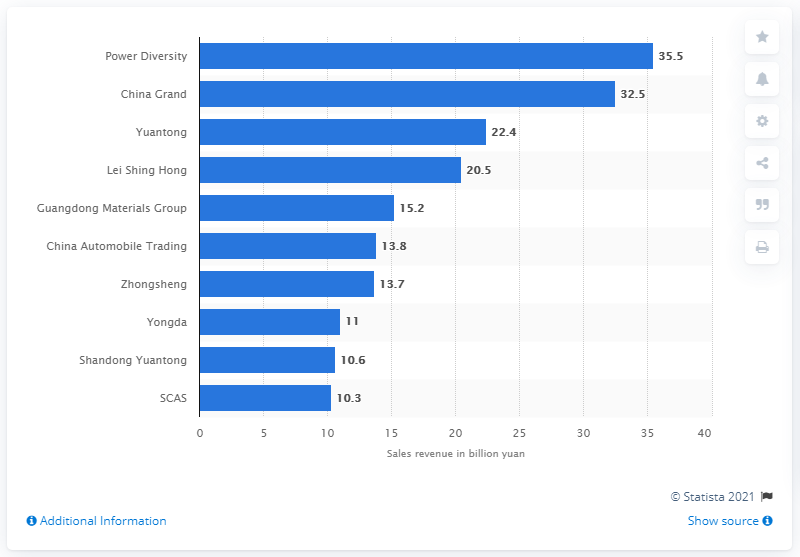Indicate a few pertinent items in this graphic. Power Diversity's revenue in 2009 was approximately $35.5 million. In 2009, the Chinese car dealer's name was "Power Diversity. 